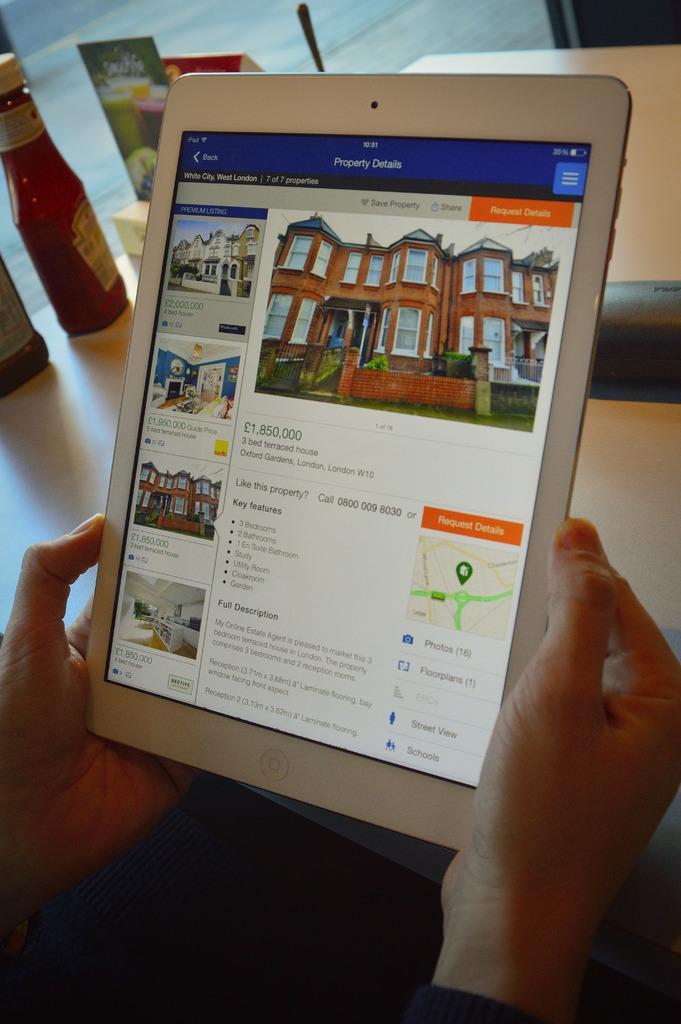In one or two sentences, can you explain what this image depicts? To the bottom of the image there are person hands holding the tab in their hands. Behind the tab there is a wooden table. To the left side of the image there are two bottles on the table. And also there is a glass door. 